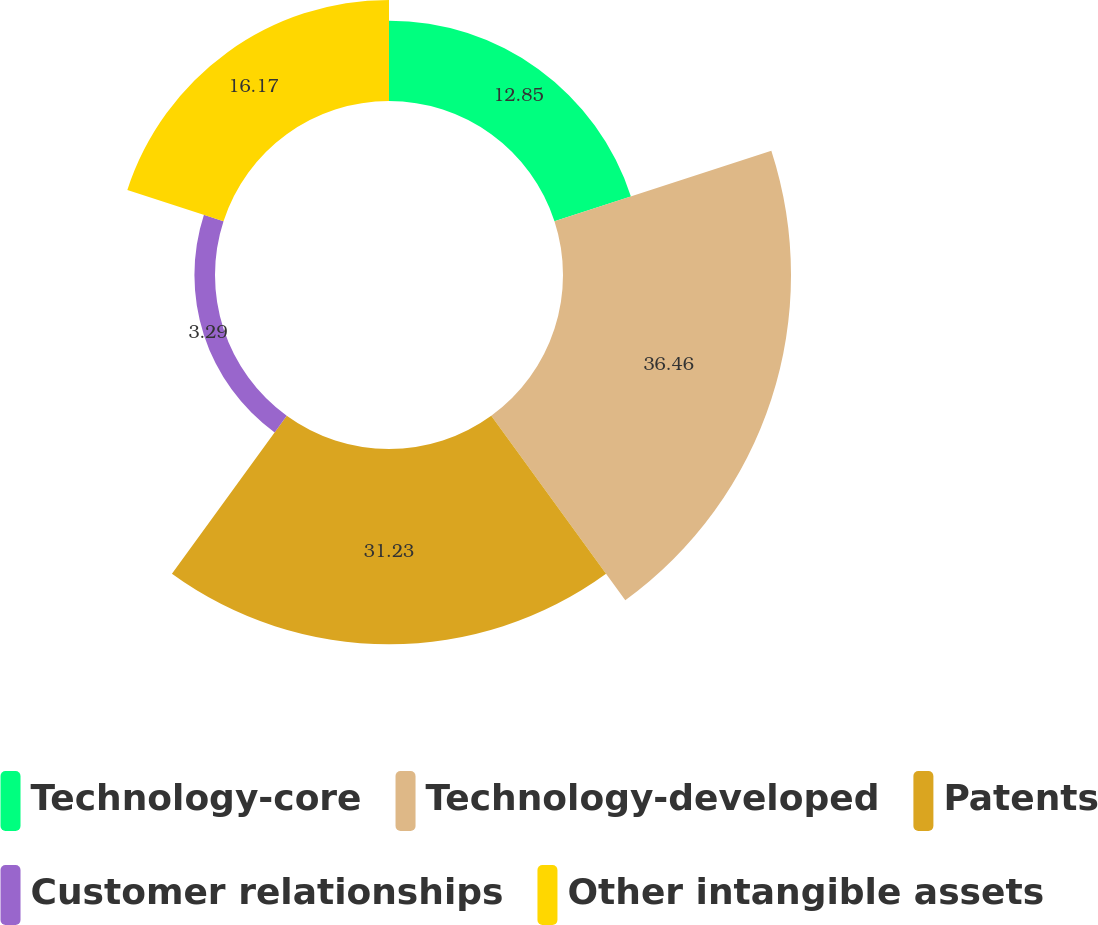<chart> <loc_0><loc_0><loc_500><loc_500><pie_chart><fcel>Technology-core<fcel>Technology-developed<fcel>Patents<fcel>Customer relationships<fcel>Other intangible assets<nl><fcel>12.85%<fcel>36.46%<fcel>31.23%<fcel>3.29%<fcel>16.17%<nl></chart> 